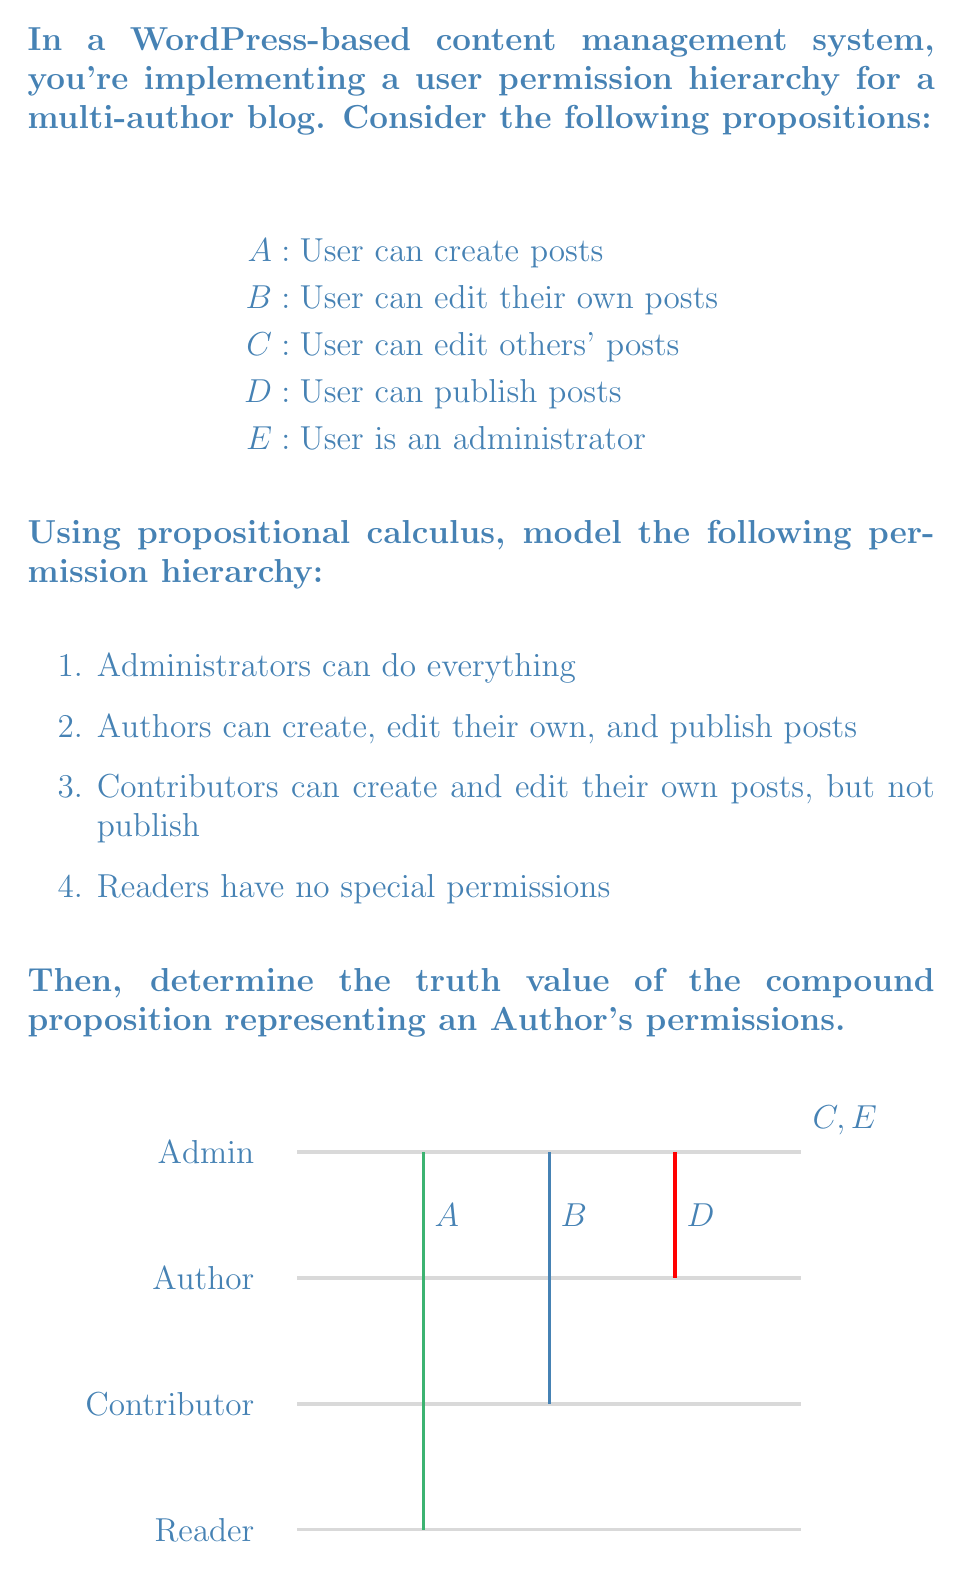Show me your answer to this math problem. Let's model the permission hierarchy using propositional calculus:

1. Administrator: $E \implies (A \land B \land C \land D)$
2. Author: $(A \land B \land D) \land \lnot E \land \lnot C$
3. Contributor: $(A \land B) \land \lnot D \land \lnot C \land \lnot E$
4. Reader: $\lnot A \land \lnot B \land \lnot C \land \lnot D \land \lnot E$

To determine the truth value of the compound proposition representing an Author's permissions, we need to evaluate:

$$(A \land B \land D) \land \lnot E \land \lnot C$$

Let's break this down step-by-step:

1. $A$ is true (Authors can create posts)
2. $B$ is true (Authors can edit their own posts)
3. $D$ is true (Authors can publish posts)
4. $\lnot E$ is true (Authors are not administrators)
5. $\lnot C$ is true (Authors cannot edit others' posts)

Now, let's evaluate the compound proposition:

$$(true \land true \land true) \land true \land true$$
$$= true \land true \land true$$
$$= true$$

Therefore, the compound proposition representing an Author's permissions evaluates to true.
Answer: True 